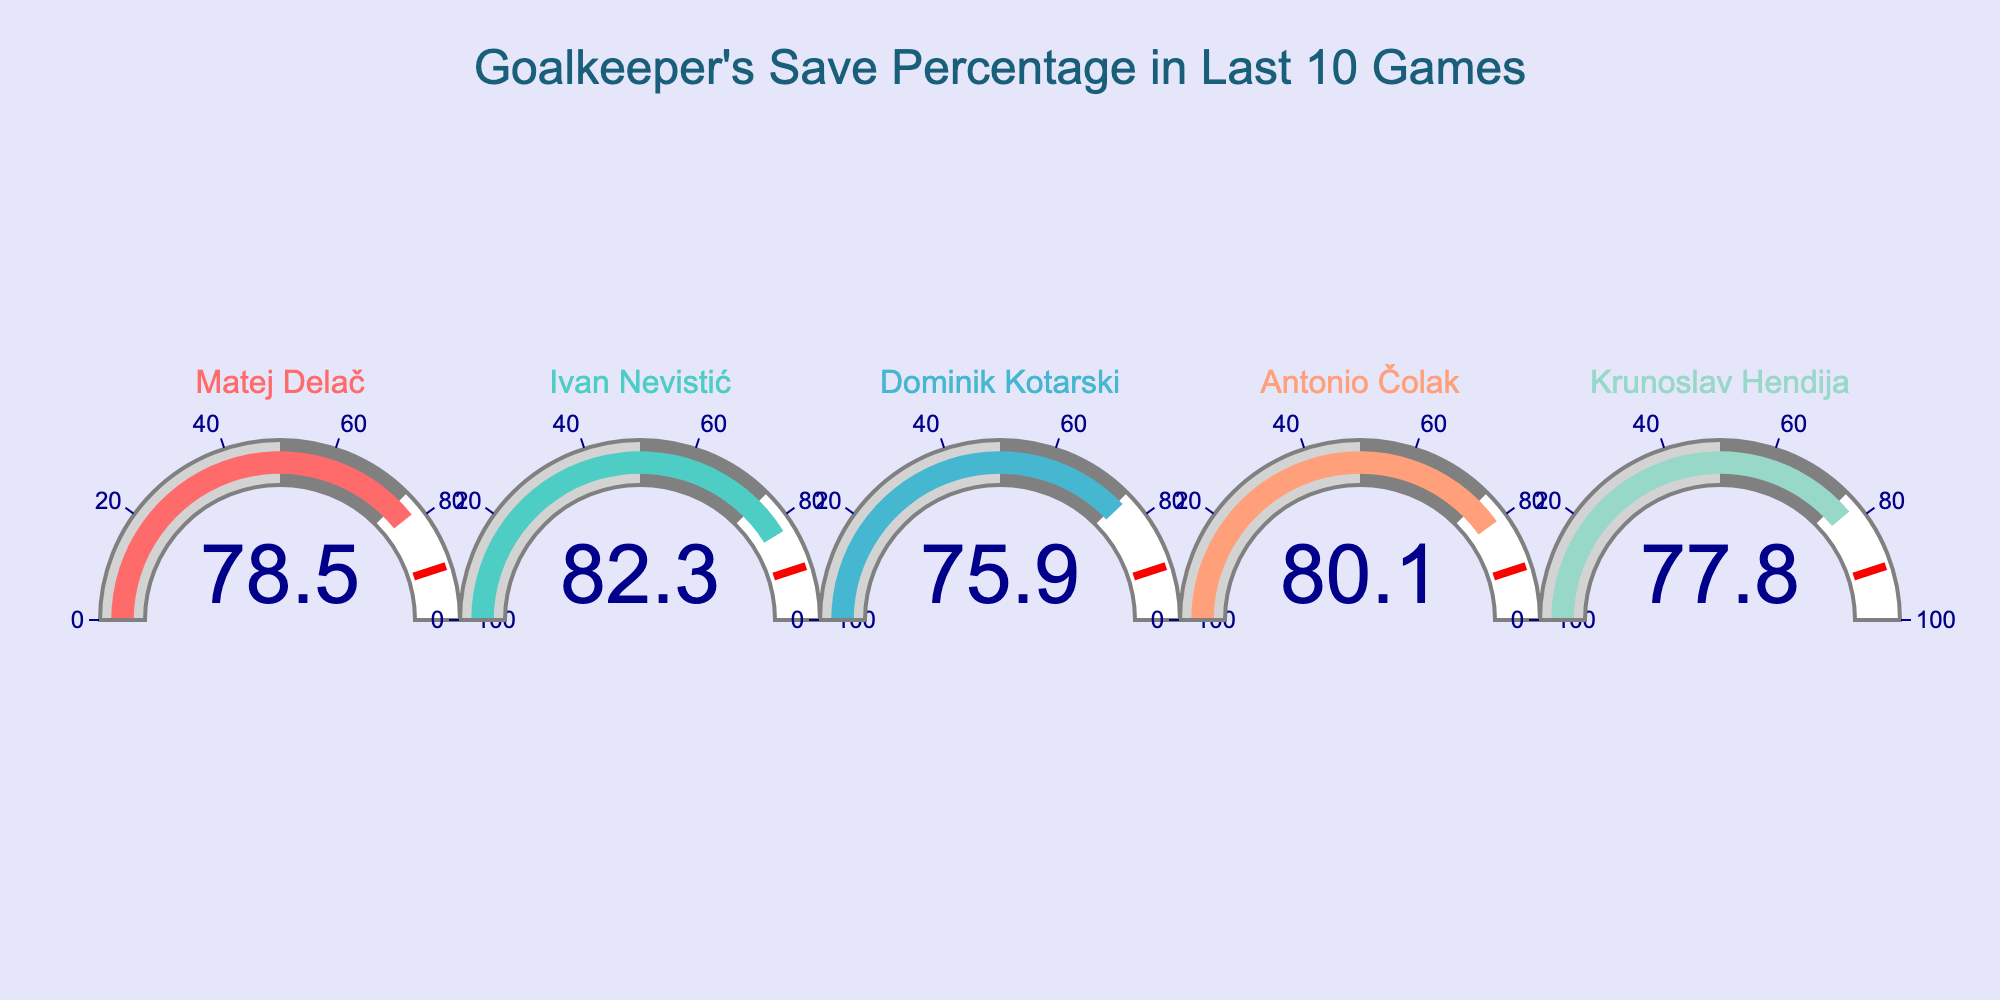What's the title of the figure? The title is placed at the top of the figure. It states, "Goalkeeper's Save Percentage in Last 10 Games"
Answer: Goalkeeper's Save Percentage in Last 10 Games How many goalkeepers are represented in the figure? There are five separate indicators in the figure, each representing a different goalkeeper.
Answer: Five Which goalkeeper has the highest save percentage, and what is it? By examining the value on each gauge, Ivan Nevistić has the highest save percentage, which is 82.3.
Answer: Ivan Nevistić - 82.3% What is the average save percentage of all the goalkeepers? First, sum up all save percentages: 78.5 (Matej Delač) + 82.3 (Ivan Nevistić) + 75.9 (Dominik Kotarski) + 80.1 (Antonio Čolak) + 77.8 (Krunoslav Hendija) = 394.6. Then, divide by the number of goalkeepers, 394.6 / 5 = 78.92
Answer: 78.92% What is the range of the save percentages? The range is found by subtracting the smallest value from the largest value. The highest is 82.3 (Ivan Nevistić), and the lowest is 75.9 (Dominik Kotarski). Thus, the range is 82.3 - 75.9 = 6.4.
Answer: 6.4 Who has the second highest save percentage? By examining the values, Antonio Čolak has the second highest save percentage, which is 80.1.
Answer: Antonio Čolak Is there any goalkeeper whose save percentage is below 80%? If so, who? Inspecting the values, Matej Delač with 78.5, Dominik Kotarski with 75.9, and Krunoslav Hendija with 77.8 have save percentages below 80%.
Answer: Matej Delač, Dominik Kotarski, Krunoslav Hendija How much greater is Ivan Nevistić's save percentage compared to Dominik Kotarski? Subtract Dominik Kotarski's save percentage from Ivan Nevistić's: 82.3 (Ivan Nevistić) - 75.9 (Dominik Kotarski) = 6.4.
Answer: 6.4 What percentage of the goalkeepers have a save percentage above 77%? Count the number of goalkeepers with save percentages above 77%: Matej Delač (78.5), Ivan Nevistić (82.3), Antonio Čolak (80.1), and Krunoslav Hendija (77.8), which is 4 goalkeepers. Divide by the total number of goalkeepers (5) and multiply by 100: (4/5) * 100 = 80%.
Answer: 80% Which goalkeeper has the closest save percentage to 80%? By examining the values, Antonio Čolak has a save percentage of 80.1, which is the closest to 80%.
Answer: Antonio Čolak 